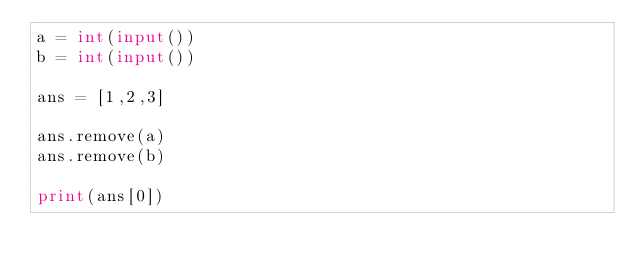<code> <loc_0><loc_0><loc_500><loc_500><_Python_>a = int(input())
b = int(input())

ans = [1,2,3]

ans.remove(a)
ans.remove(b)

print(ans[0])
</code> 